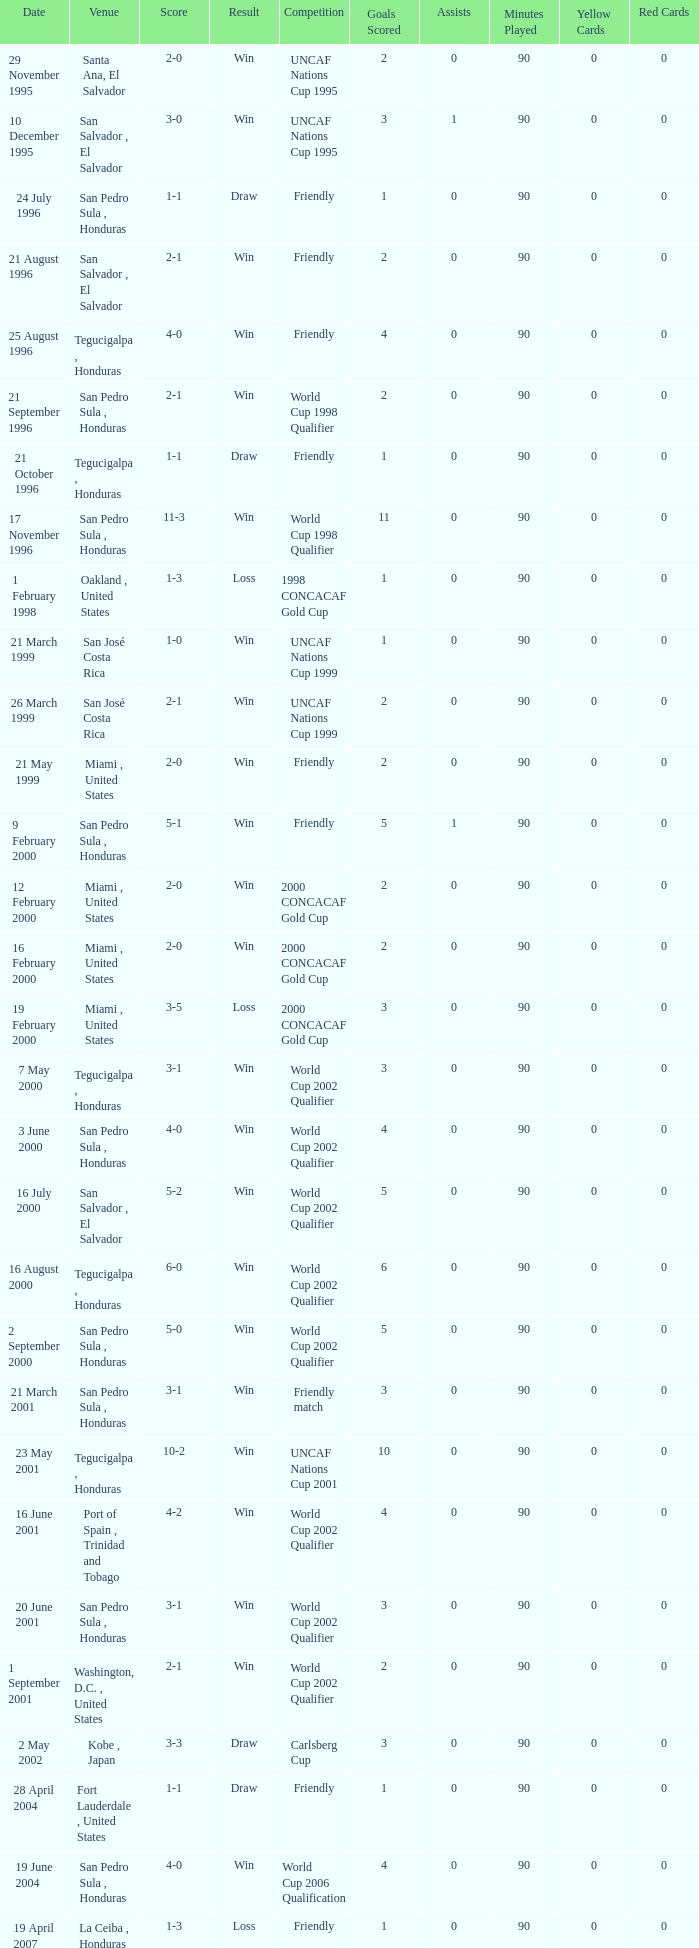Name the score for 7 may 2000 3-1. 